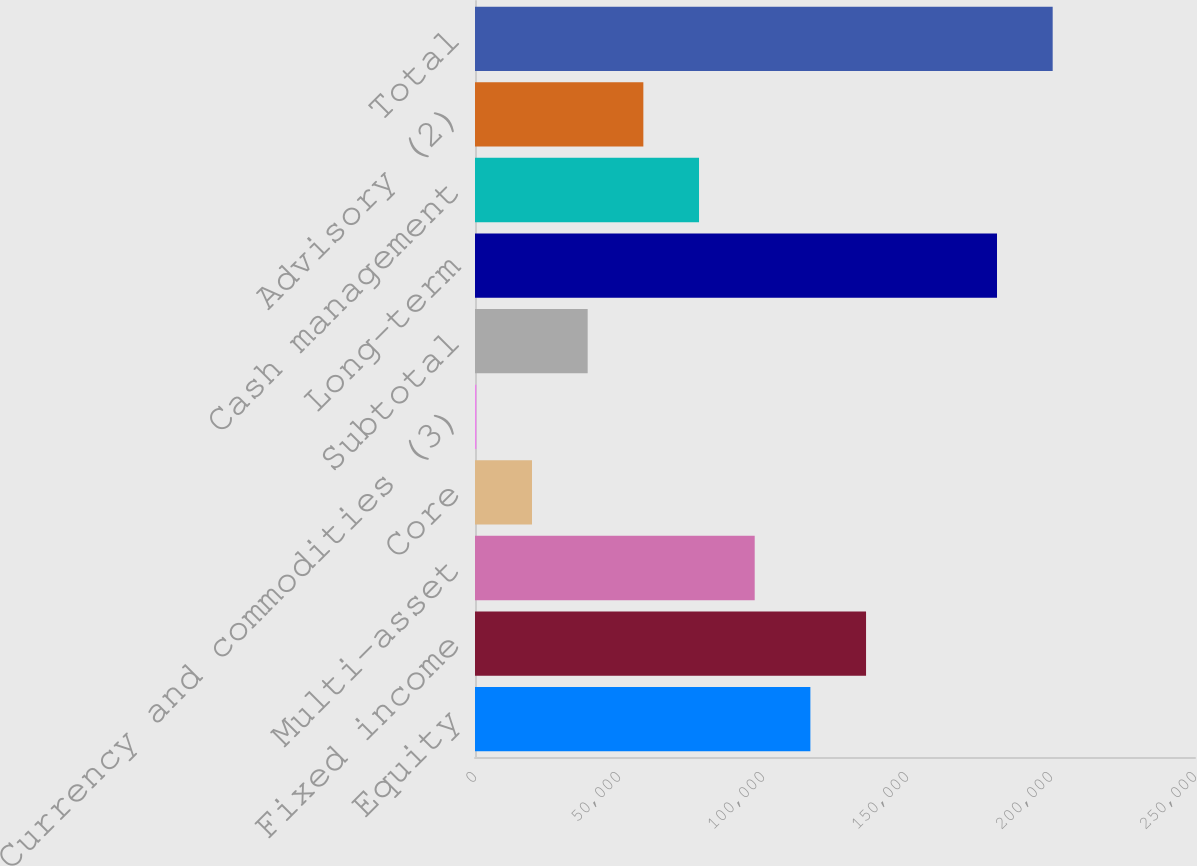Convert chart to OTSL. <chart><loc_0><loc_0><loc_500><loc_500><bar_chart><fcel>Equity<fcel>Fixed income<fcel>Multi-asset<fcel>Core<fcel>Currency and commodities (3)<fcel>Subtotal<fcel>Long-term<fcel>Cash management<fcel>Advisory (2)<fcel>Total<nl><fcel>116450<fcel>135782<fcel>97118.5<fcel>19792.5<fcel>461<fcel>39124<fcel>181253<fcel>77787<fcel>58455.5<fcel>200584<nl></chart> 